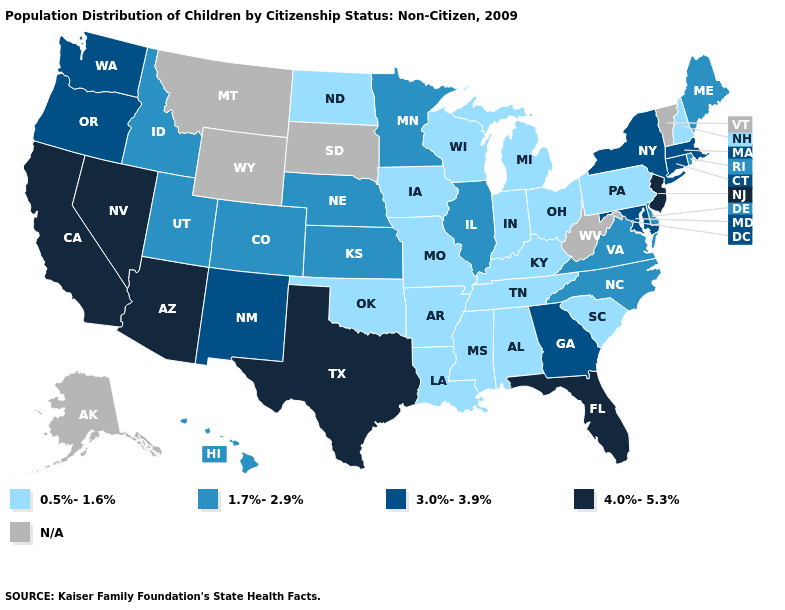Which states hav the highest value in the MidWest?
Be succinct. Illinois, Kansas, Minnesota, Nebraska. What is the value of Arizona?
Keep it brief. 4.0%-5.3%. Does the first symbol in the legend represent the smallest category?
Be succinct. Yes. Name the states that have a value in the range 4.0%-5.3%?
Keep it brief. Arizona, California, Florida, Nevada, New Jersey, Texas. Which states have the highest value in the USA?
Give a very brief answer. Arizona, California, Florida, Nevada, New Jersey, Texas. Name the states that have a value in the range 3.0%-3.9%?
Keep it brief. Connecticut, Georgia, Maryland, Massachusetts, New Mexico, New York, Oregon, Washington. Name the states that have a value in the range N/A?
Concise answer only. Alaska, Montana, South Dakota, Vermont, West Virginia, Wyoming. What is the value of New Hampshire?
Quick response, please. 0.5%-1.6%. What is the value of Maryland?
Answer briefly. 3.0%-3.9%. Does Kansas have the highest value in the MidWest?
Write a very short answer. Yes. Does the map have missing data?
Give a very brief answer. Yes. What is the value of Washington?
Quick response, please. 3.0%-3.9%. Which states have the lowest value in the USA?
Give a very brief answer. Alabama, Arkansas, Indiana, Iowa, Kentucky, Louisiana, Michigan, Mississippi, Missouri, New Hampshire, North Dakota, Ohio, Oklahoma, Pennsylvania, South Carolina, Tennessee, Wisconsin. What is the value of Tennessee?
Concise answer only. 0.5%-1.6%. 